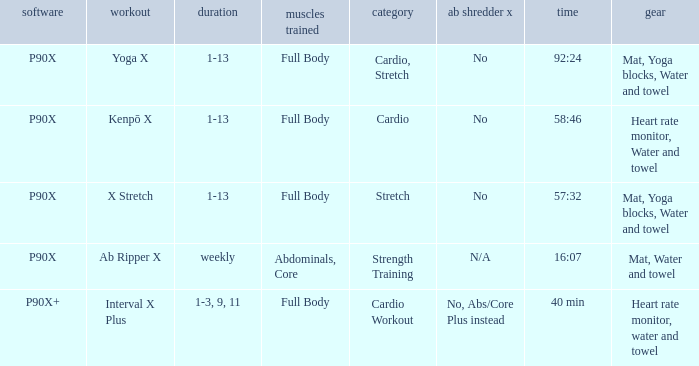How many types are cardio? 1.0. 